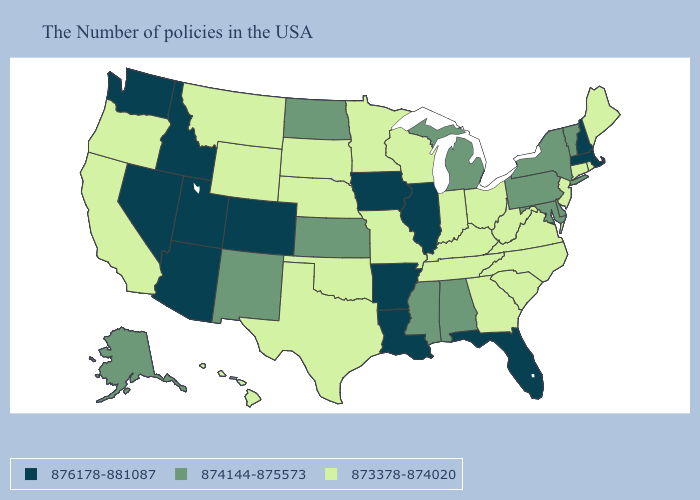Name the states that have a value in the range 876178-881087?
Short answer required. Massachusetts, New Hampshire, Florida, Illinois, Louisiana, Arkansas, Iowa, Colorado, Utah, Arizona, Idaho, Nevada, Washington. What is the highest value in states that border North Dakota?
Give a very brief answer. 873378-874020. Does Maine have the highest value in the USA?
Give a very brief answer. No. What is the value of Rhode Island?
Write a very short answer. 873378-874020. What is the value of Nebraska?
Keep it brief. 873378-874020. Does the map have missing data?
Give a very brief answer. No. Among the states that border New Mexico , which have the highest value?
Keep it brief. Colorado, Utah, Arizona. What is the lowest value in the West?
Keep it brief. 873378-874020. Does Indiana have the highest value in the USA?
Concise answer only. No. What is the value of Virginia?
Keep it brief. 873378-874020. What is the value of Pennsylvania?
Concise answer only. 874144-875573. What is the value of Mississippi?
Be succinct. 874144-875573. 